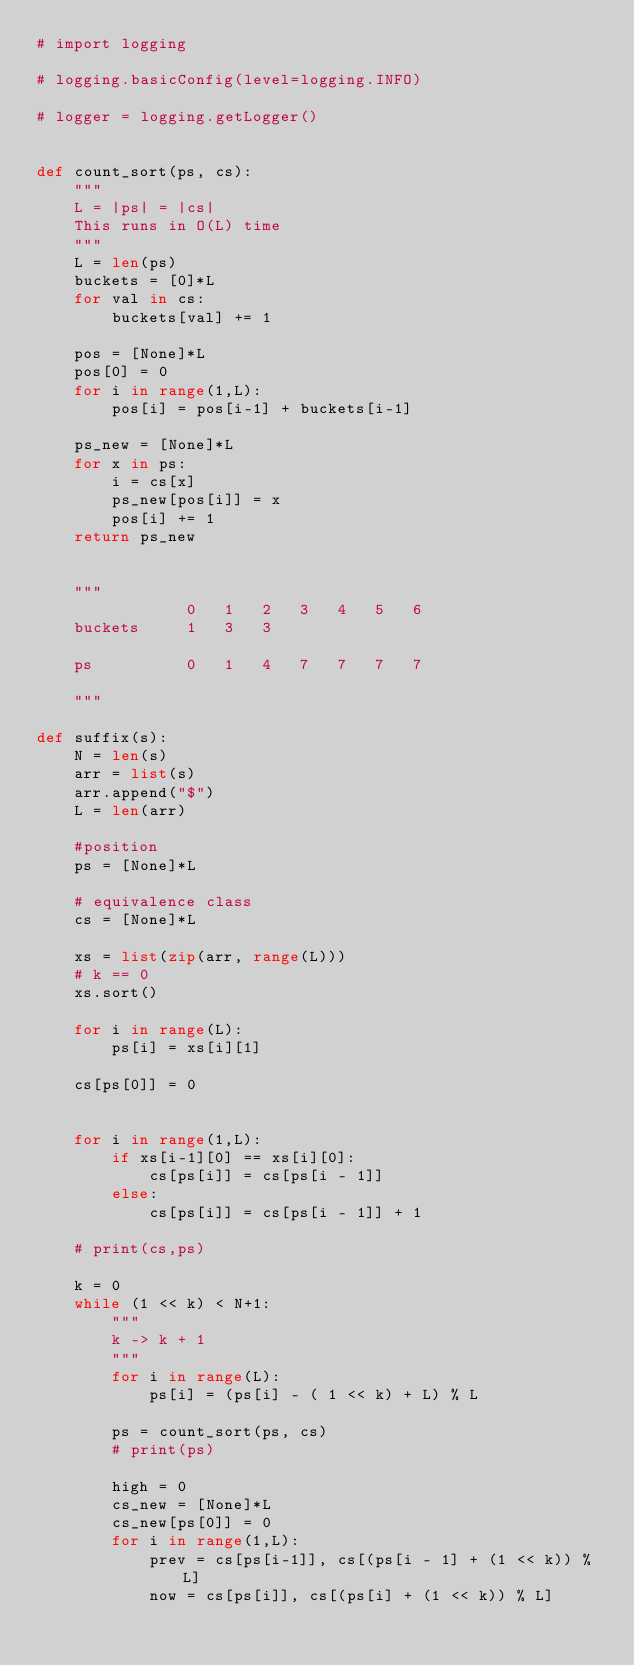<code> <loc_0><loc_0><loc_500><loc_500><_Python_># import logging

# logging.basicConfig(level=logging.INFO)

# logger = logging.getLogger()


def count_sort(ps, cs):
    """
    L = |ps| = |cs|
    This runs in O(L) time
    """
    L = len(ps)
    buckets = [0]*L
    for val in cs:
        buckets[val] += 1

    pos = [None]*L
    pos[0] = 0
    for i in range(1,L):
        pos[i] = pos[i-1] + buckets[i-1]

    ps_new = [None]*L
    for x in ps:
        i = cs[x]
        ps_new[pos[i]] = x
        pos[i] += 1
    return ps_new

    
    """
                0   1   2   3   4   5   6
    buckets     1   3   3

    ps          0   1   4   7   7   7   7
    
    """

def suffix(s):
    N = len(s)
    arr = list(s)
    arr.append("$")
    L = len(arr)

    #position
    ps = [None]*L

    # equivalence class
    cs = [None]*L

    xs = list(zip(arr, range(L)))
    # k == 0
    xs.sort()
    
    for i in range(L):
        ps[i] = xs[i][1]

    cs[ps[0]] = 0
    
    
    for i in range(1,L):
        if xs[i-1][0] == xs[i][0]:
            cs[ps[i]] = cs[ps[i - 1]]
        else:
            cs[ps[i]] = cs[ps[i - 1]] + 1

    # print(cs,ps)

    k = 0
    while (1 << k) < N+1:
        """
        k -> k + 1
        """
        for i in range(L):
            ps[i] = (ps[i] - ( 1 << k) + L) % L

        ps = count_sort(ps, cs)
        # print(ps)
        
        high = 0
        cs_new = [None]*L
        cs_new[ps[0]] = 0
        for i in range(1,L):
            prev = cs[ps[i-1]], cs[(ps[i - 1] + (1 << k)) % L]
            now = cs[ps[i]], cs[(ps[i] + (1 << k)) % L]</code> 